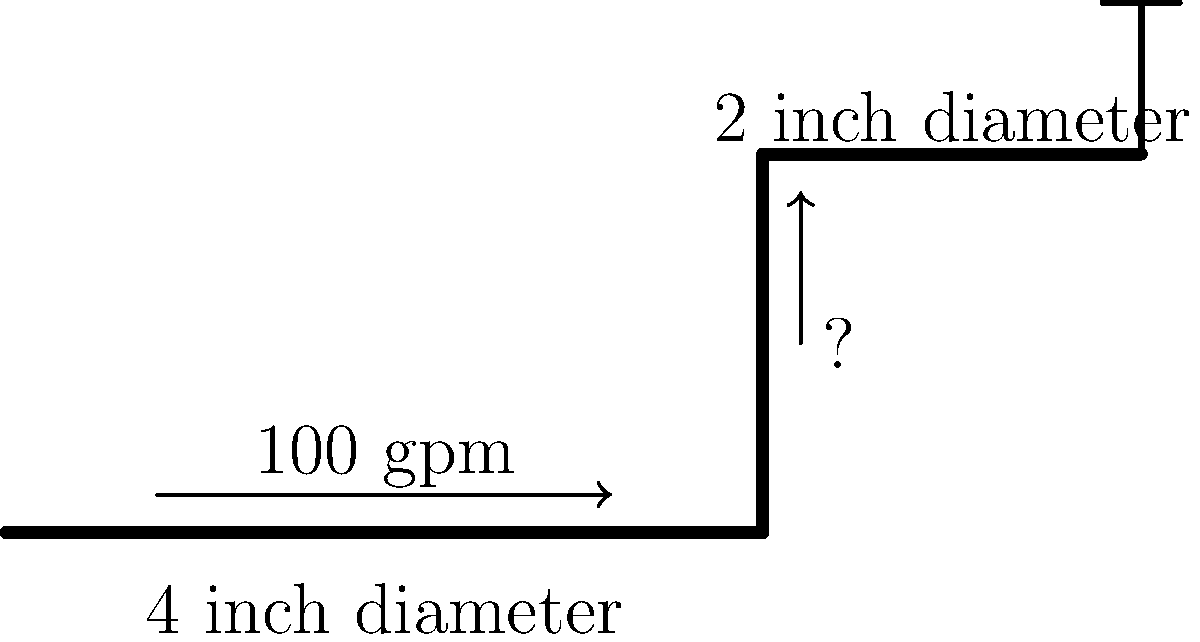Your farmer relative is setting up a new sprinkler system for the corn field. The main pipe has a 4-inch diameter and carries 100 gallons per minute (gpm) of water. It branches into a 2-inch diameter pipe that leads to a sprinkler. Using the continuity equation, calculate the flow rate in the 2-inch pipe. (Assume no water loss in the system) Let's approach this step-by-step:

1) The continuity equation states that the flow rate (Q) is equal to the velocity (v) multiplied by the cross-sectional area (A) of the pipe:

   $Q = v \times A$

2) We know that the flow rate in the 4-inch pipe is 100 gpm. This flow rate must be conserved throughout the system (assuming no water loss).

3) To find the flow rate in the 2-inch pipe, we need to consider the ratio of the pipe areas:

   $A_1 = \pi r_1^2$ and $A_2 = \pi r_2^2$

   Where $r_1$ is the radius of the 4-inch pipe and $r_2$ is the radius of the 2-inch pipe.

4) The ratio of the areas is:

   $\frac{A_2}{A_1} = \frac{\pi r_2^2}{\pi r_1^2} = \frac{r_2^2}{r_1^2} = \frac{1^2}{2^2} = \frac{1}{4}$

5) Since the flow rate is proportional to the area (given constant velocity), the flow rate in the 2-inch pipe will be 1/4 of the flow rate in the 4-inch pipe:

   $Q_2 = \frac{1}{4} \times Q_1 = \frac{1}{4} \times 100 \text{ gpm} = 25 \text{ gpm}$

Therefore, the flow rate in the 2-inch pipe leading to the sprinkler is 25 gpm.
Answer: 25 gpm 